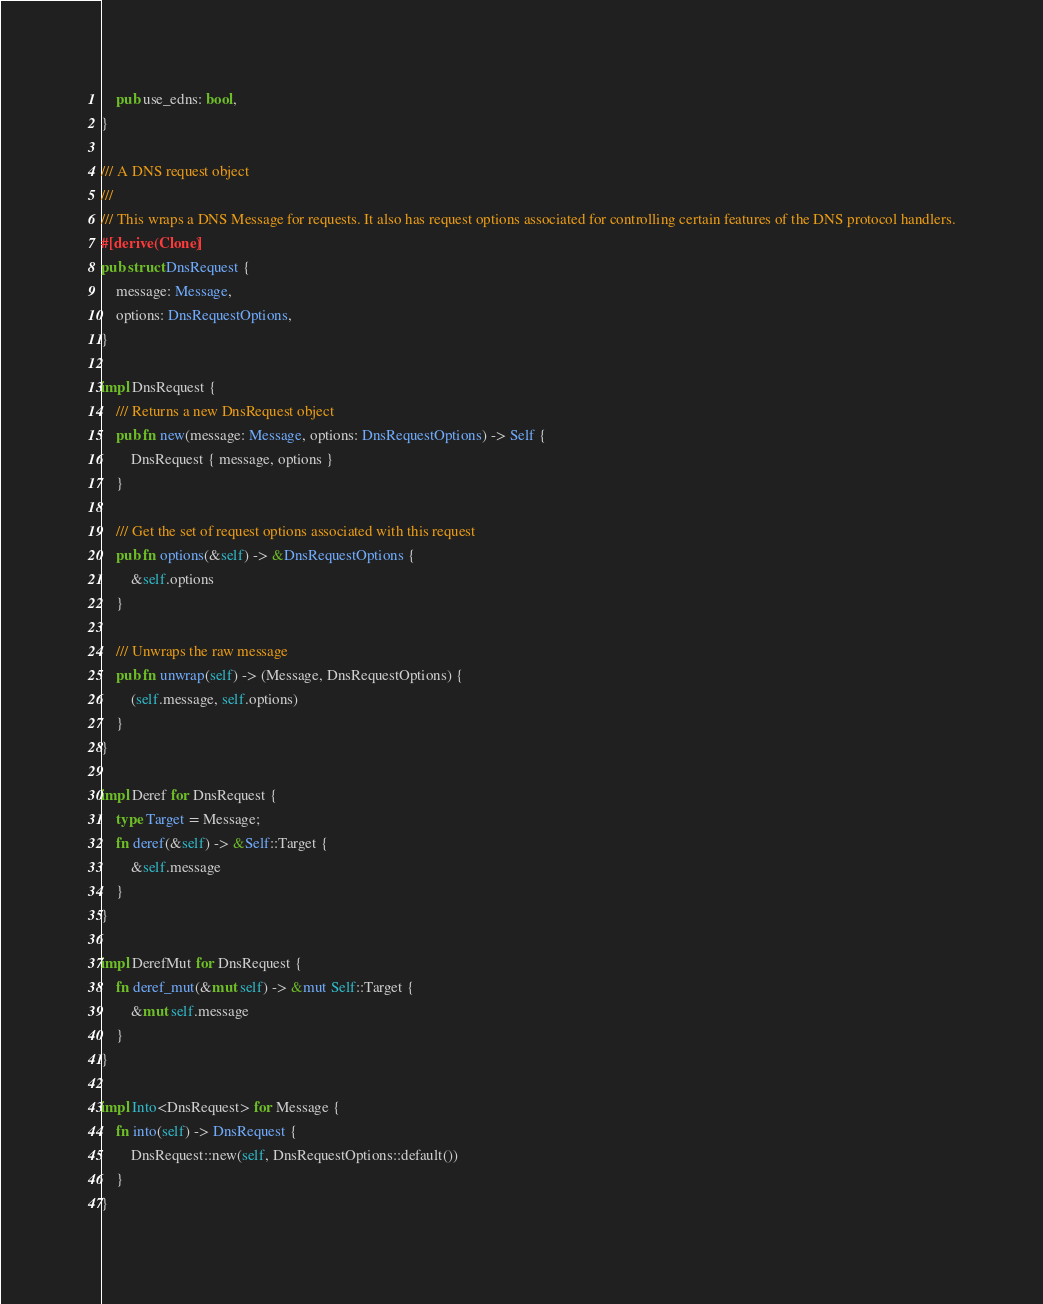Convert code to text. <code><loc_0><loc_0><loc_500><loc_500><_Rust_>    pub use_edns: bool,
}

/// A DNS request object
///
/// This wraps a DNS Message for requests. It also has request options associated for controlling certain features of the DNS protocol handlers.
#[derive(Clone)]
pub struct DnsRequest {
    message: Message,
    options: DnsRequestOptions,
}

impl DnsRequest {
    /// Returns a new DnsRequest object
    pub fn new(message: Message, options: DnsRequestOptions) -> Self {
        DnsRequest { message, options }
    }

    /// Get the set of request options associated with this request
    pub fn options(&self) -> &DnsRequestOptions {
        &self.options
    }

    /// Unwraps the raw message
    pub fn unwrap(self) -> (Message, DnsRequestOptions) {
        (self.message, self.options)
    }
}

impl Deref for DnsRequest {
    type Target = Message;
    fn deref(&self) -> &Self::Target {
        &self.message
    }
}

impl DerefMut for DnsRequest {
    fn deref_mut(&mut self) -> &mut Self::Target {
        &mut self.message
    }
}

impl Into<DnsRequest> for Message {
    fn into(self) -> DnsRequest {
        DnsRequest::new(self, DnsRequestOptions::default())
    }
}
</code> 